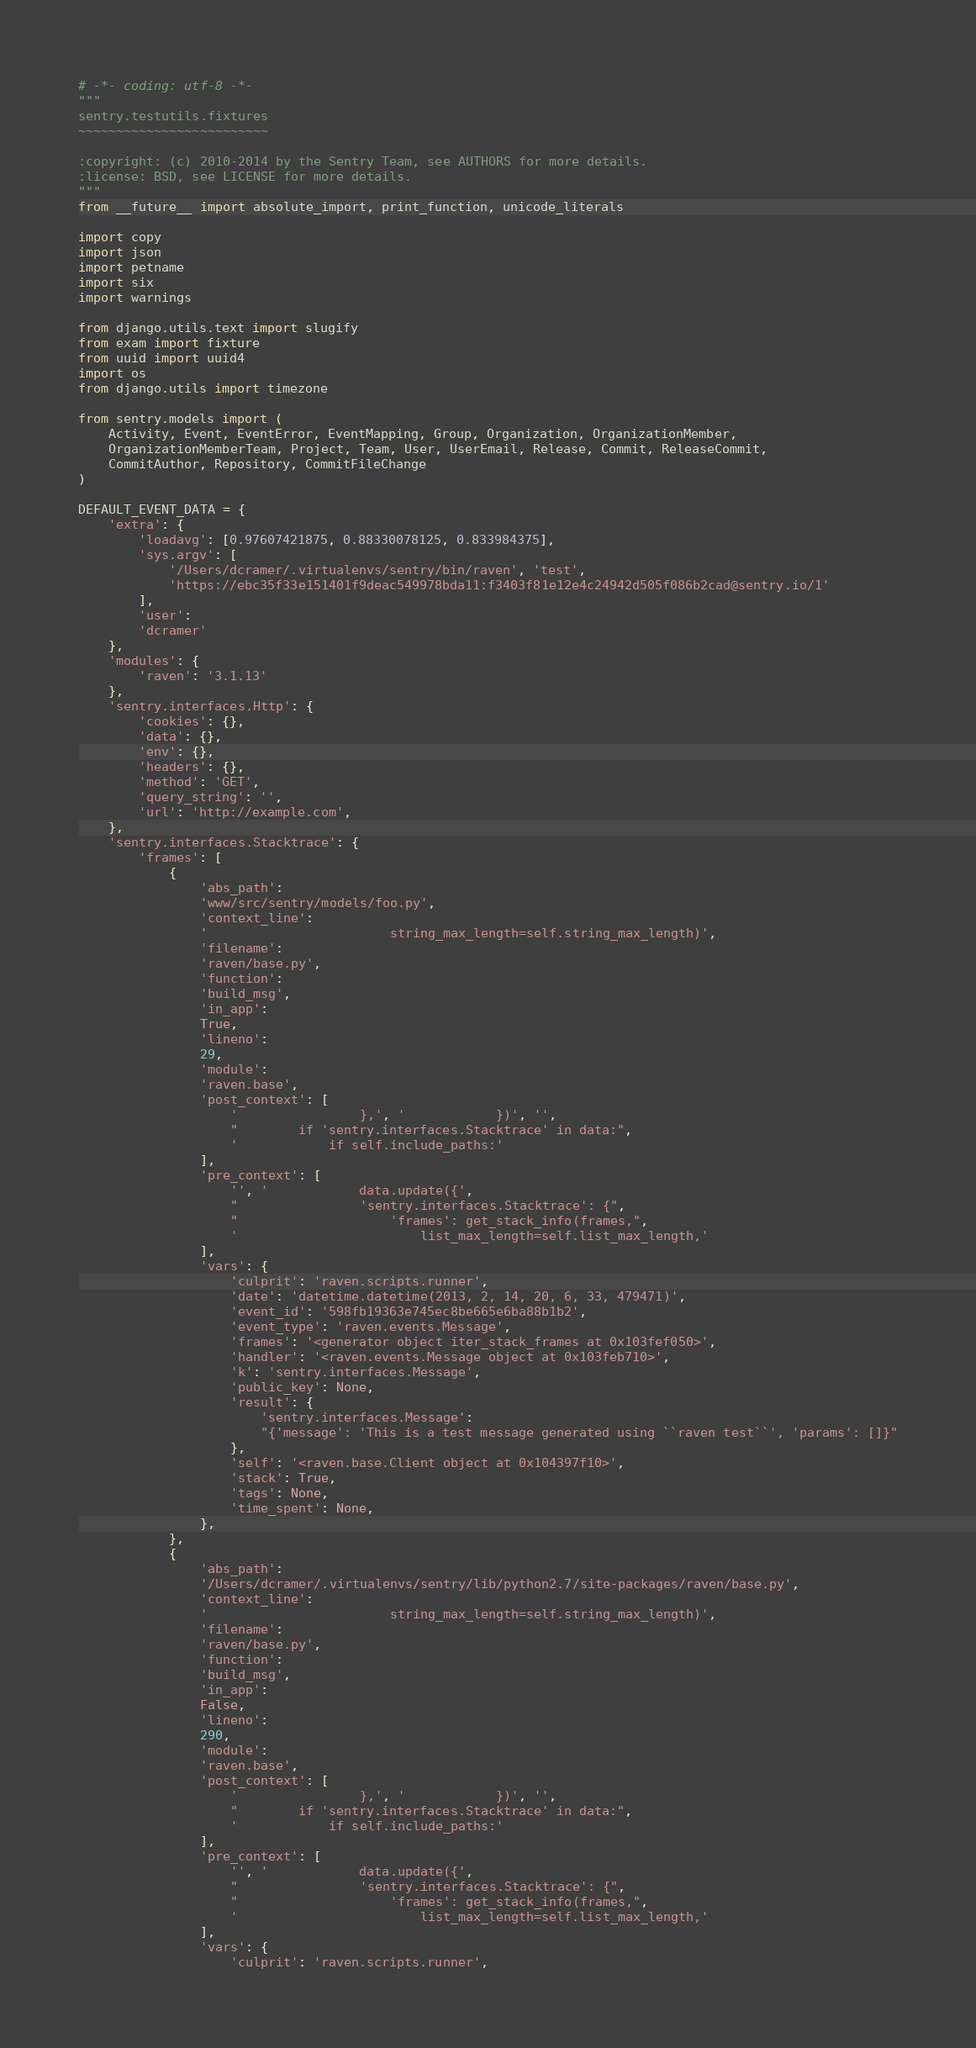Convert code to text. <code><loc_0><loc_0><loc_500><loc_500><_Python_># -*- coding: utf-8 -*-
"""
sentry.testutils.fixtures
~~~~~~~~~~~~~~~~~~~~~~~~~

:copyright: (c) 2010-2014 by the Sentry Team, see AUTHORS for more details.
:license: BSD, see LICENSE for more details.
"""
from __future__ import absolute_import, print_function, unicode_literals

import copy
import json
import petname
import six
import warnings

from django.utils.text import slugify
from exam import fixture
from uuid import uuid4
import os
from django.utils import timezone

from sentry.models import (
    Activity, Event, EventError, EventMapping, Group, Organization, OrganizationMember,
    OrganizationMemberTeam, Project, Team, User, UserEmail, Release, Commit, ReleaseCommit,
    CommitAuthor, Repository, CommitFileChange
)

DEFAULT_EVENT_DATA = {
    'extra': {
        'loadavg': [0.97607421875, 0.88330078125, 0.833984375],
        'sys.argv': [
            '/Users/dcramer/.virtualenvs/sentry/bin/raven', 'test',
            'https://ebc35f33e151401f9deac549978bda11:f3403f81e12e4c24942d505f086b2cad@sentry.io/1'
        ],
        'user':
        'dcramer'
    },
    'modules': {
        'raven': '3.1.13'
    },
    'sentry.interfaces.Http': {
        'cookies': {},
        'data': {},
        'env': {},
        'headers': {},
        'method': 'GET',
        'query_string': '',
        'url': 'http://example.com',
    },
    'sentry.interfaces.Stacktrace': {
        'frames': [
            {
                'abs_path':
                'www/src/sentry/models/foo.py',
                'context_line':
                '                        string_max_length=self.string_max_length)',
                'filename':
                'raven/base.py',
                'function':
                'build_msg',
                'in_app':
                True,
                'lineno':
                29,
                'module':
                'raven.base',
                'post_context': [
                    '                },', '            })', '',
                    "        if 'sentry.interfaces.Stacktrace' in data:",
                    '            if self.include_paths:'
                ],
                'pre_context': [
                    '', '            data.update({',
                    "                'sentry.interfaces.Stacktrace': {",
                    "                    'frames': get_stack_info(frames,",
                    '                        list_max_length=self.list_max_length,'
                ],
                'vars': {
                    'culprit': 'raven.scripts.runner',
                    'date': 'datetime.datetime(2013, 2, 14, 20, 6, 33, 479471)',
                    'event_id': '598fb19363e745ec8be665e6ba88b1b2',
                    'event_type': 'raven.events.Message',
                    'frames': '<generator object iter_stack_frames at 0x103fef050>',
                    'handler': '<raven.events.Message object at 0x103feb710>',
                    'k': 'sentry.interfaces.Message',
                    'public_key': None,
                    'result': {
                        'sentry.interfaces.Message':
                        "{'message': 'This is a test message generated using ``raven test``', 'params': []}"
                    },
                    'self': '<raven.base.Client object at 0x104397f10>',
                    'stack': True,
                    'tags': None,
                    'time_spent': None,
                },
            },
            {
                'abs_path':
                '/Users/dcramer/.virtualenvs/sentry/lib/python2.7/site-packages/raven/base.py',
                'context_line':
                '                        string_max_length=self.string_max_length)',
                'filename':
                'raven/base.py',
                'function':
                'build_msg',
                'in_app':
                False,
                'lineno':
                290,
                'module':
                'raven.base',
                'post_context': [
                    '                },', '            })', '',
                    "        if 'sentry.interfaces.Stacktrace' in data:",
                    '            if self.include_paths:'
                ],
                'pre_context': [
                    '', '            data.update({',
                    "                'sentry.interfaces.Stacktrace': {",
                    "                    'frames': get_stack_info(frames,",
                    '                        list_max_length=self.list_max_length,'
                ],
                'vars': {
                    'culprit': 'raven.scripts.runner',</code> 